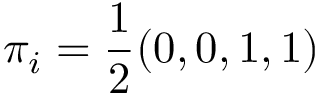<formula> <loc_0><loc_0><loc_500><loc_500>\pi _ { i } = \frac { 1 } { 2 } ( 0 , 0 , 1 , 1 )</formula> 